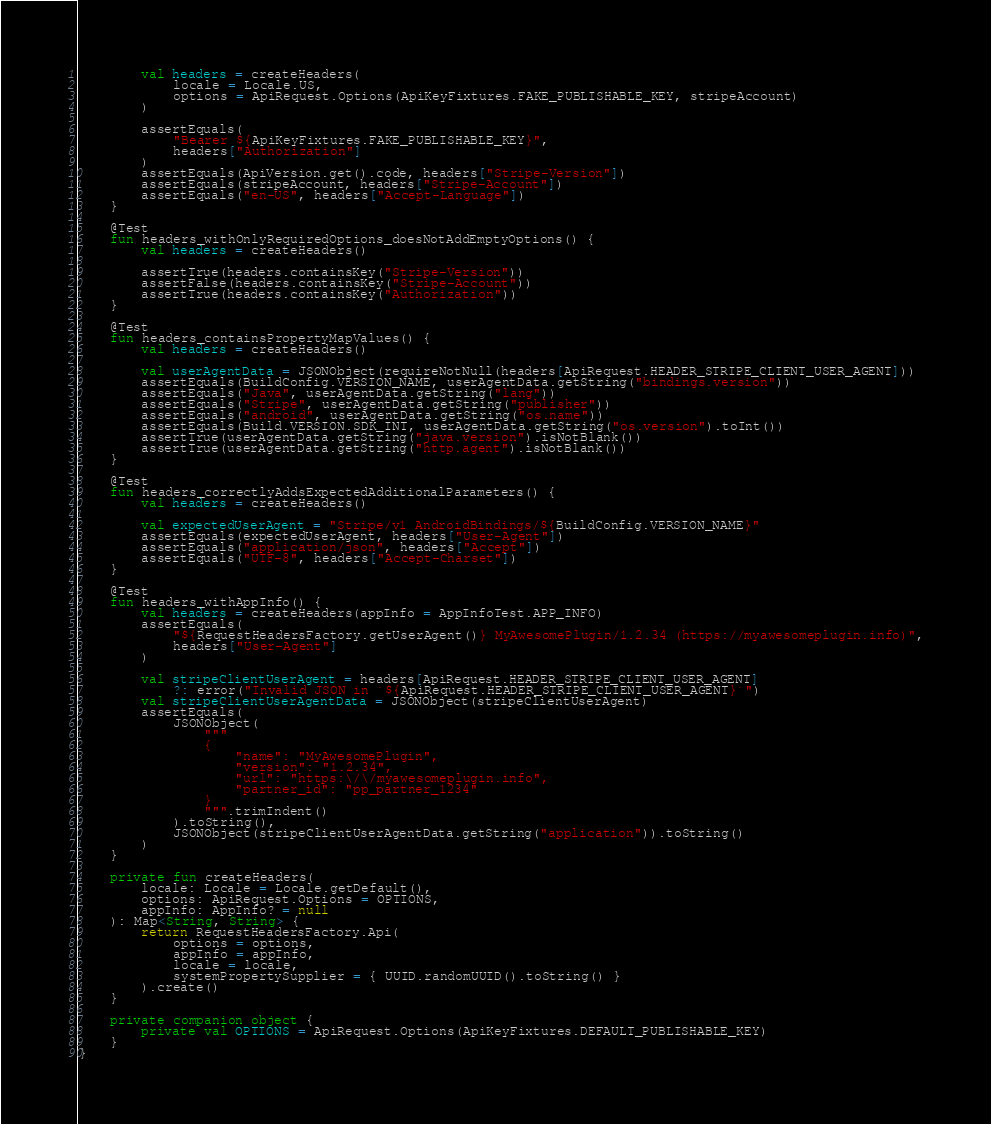Convert code to text. <code><loc_0><loc_0><loc_500><loc_500><_Kotlin_>        val headers = createHeaders(
            locale = Locale.US,
            options = ApiRequest.Options(ApiKeyFixtures.FAKE_PUBLISHABLE_KEY, stripeAccount)
        )

        assertEquals(
            "Bearer ${ApiKeyFixtures.FAKE_PUBLISHABLE_KEY}",
            headers["Authorization"]
        )
        assertEquals(ApiVersion.get().code, headers["Stripe-Version"])
        assertEquals(stripeAccount, headers["Stripe-Account"])
        assertEquals("en-US", headers["Accept-Language"])
    }

    @Test
    fun headers_withOnlyRequiredOptions_doesNotAddEmptyOptions() {
        val headers = createHeaders()

        assertTrue(headers.containsKey("Stripe-Version"))
        assertFalse(headers.containsKey("Stripe-Account"))
        assertTrue(headers.containsKey("Authorization"))
    }

    @Test
    fun headers_containsPropertyMapValues() {
        val headers = createHeaders()

        val userAgentData = JSONObject(requireNotNull(headers[ApiRequest.HEADER_STRIPE_CLIENT_USER_AGENT]))
        assertEquals(BuildConfig.VERSION_NAME, userAgentData.getString("bindings.version"))
        assertEquals("Java", userAgentData.getString("lang"))
        assertEquals("Stripe", userAgentData.getString("publisher"))
        assertEquals("android", userAgentData.getString("os.name"))
        assertEquals(Build.VERSION.SDK_INT, userAgentData.getString("os.version").toInt())
        assertTrue(userAgentData.getString("java.version").isNotBlank())
        assertTrue(userAgentData.getString("http.agent").isNotBlank())
    }

    @Test
    fun headers_correctlyAddsExpectedAdditionalParameters() {
        val headers = createHeaders()

        val expectedUserAgent = "Stripe/v1 AndroidBindings/${BuildConfig.VERSION_NAME}"
        assertEquals(expectedUserAgent, headers["User-Agent"])
        assertEquals("application/json", headers["Accept"])
        assertEquals("UTF-8", headers["Accept-Charset"])
    }

    @Test
    fun headers_withAppInfo() {
        val headers = createHeaders(appInfo = AppInfoTest.APP_INFO)
        assertEquals(
            "${RequestHeadersFactory.getUserAgent()} MyAwesomePlugin/1.2.34 (https://myawesomeplugin.info)",
            headers["User-Agent"]
        )

        val stripeClientUserAgent = headers[ApiRequest.HEADER_STRIPE_CLIENT_USER_AGENT]
            ?: error("Invalid JSON in `${ApiRequest.HEADER_STRIPE_CLIENT_USER_AGENT}`")
        val stripeClientUserAgentData = JSONObject(stripeClientUserAgent)
        assertEquals(
            JSONObject(
                """
                {
                    "name": "MyAwesomePlugin",
                    "version": "1.2.34",
                    "url": "https:\/\/myawesomeplugin.info",
                    "partner_id": "pp_partner_1234"
                }
                """.trimIndent()
            ).toString(),
            JSONObject(stripeClientUserAgentData.getString("application")).toString()
        )
    }

    private fun createHeaders(
        locale: Locale = Locale.getDefault(),
        options: ApiRequest.Options = OPTIONS,
        appInfo: AppInfo? = null
    ): Map<String, String> {
        return RequestHeadersFactory.Api(
            options = options,
            appInfo = appInfo,
            locale = locale,
            systemPropertySupplier = { UUID.randomUUID().toString() }
        ).create()
    }

    private companion object {
        private val OPTIONS = ApiRequest.Options(ApiKeyFixtures.DEFAULT_PUBLISHABLE_KEY)
    }
}
</code> 